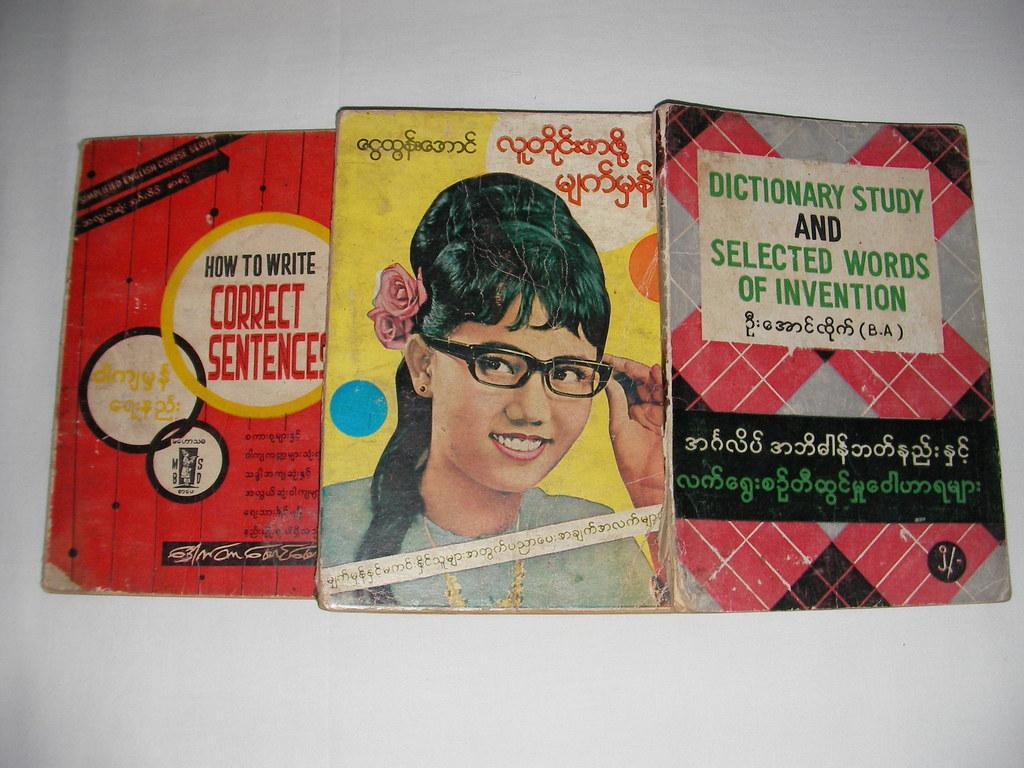How many books are visible in the image? There are three books in the image. What is the color of the surface on which the books are placed? The books are on a white surface. Where are the books located in relation to the image? The books are in the foreground of the image. What type of teeth can be seen in the image? There are no teeth present in the image. How many chickens are visible in the image? There are no chickens present in the image. 